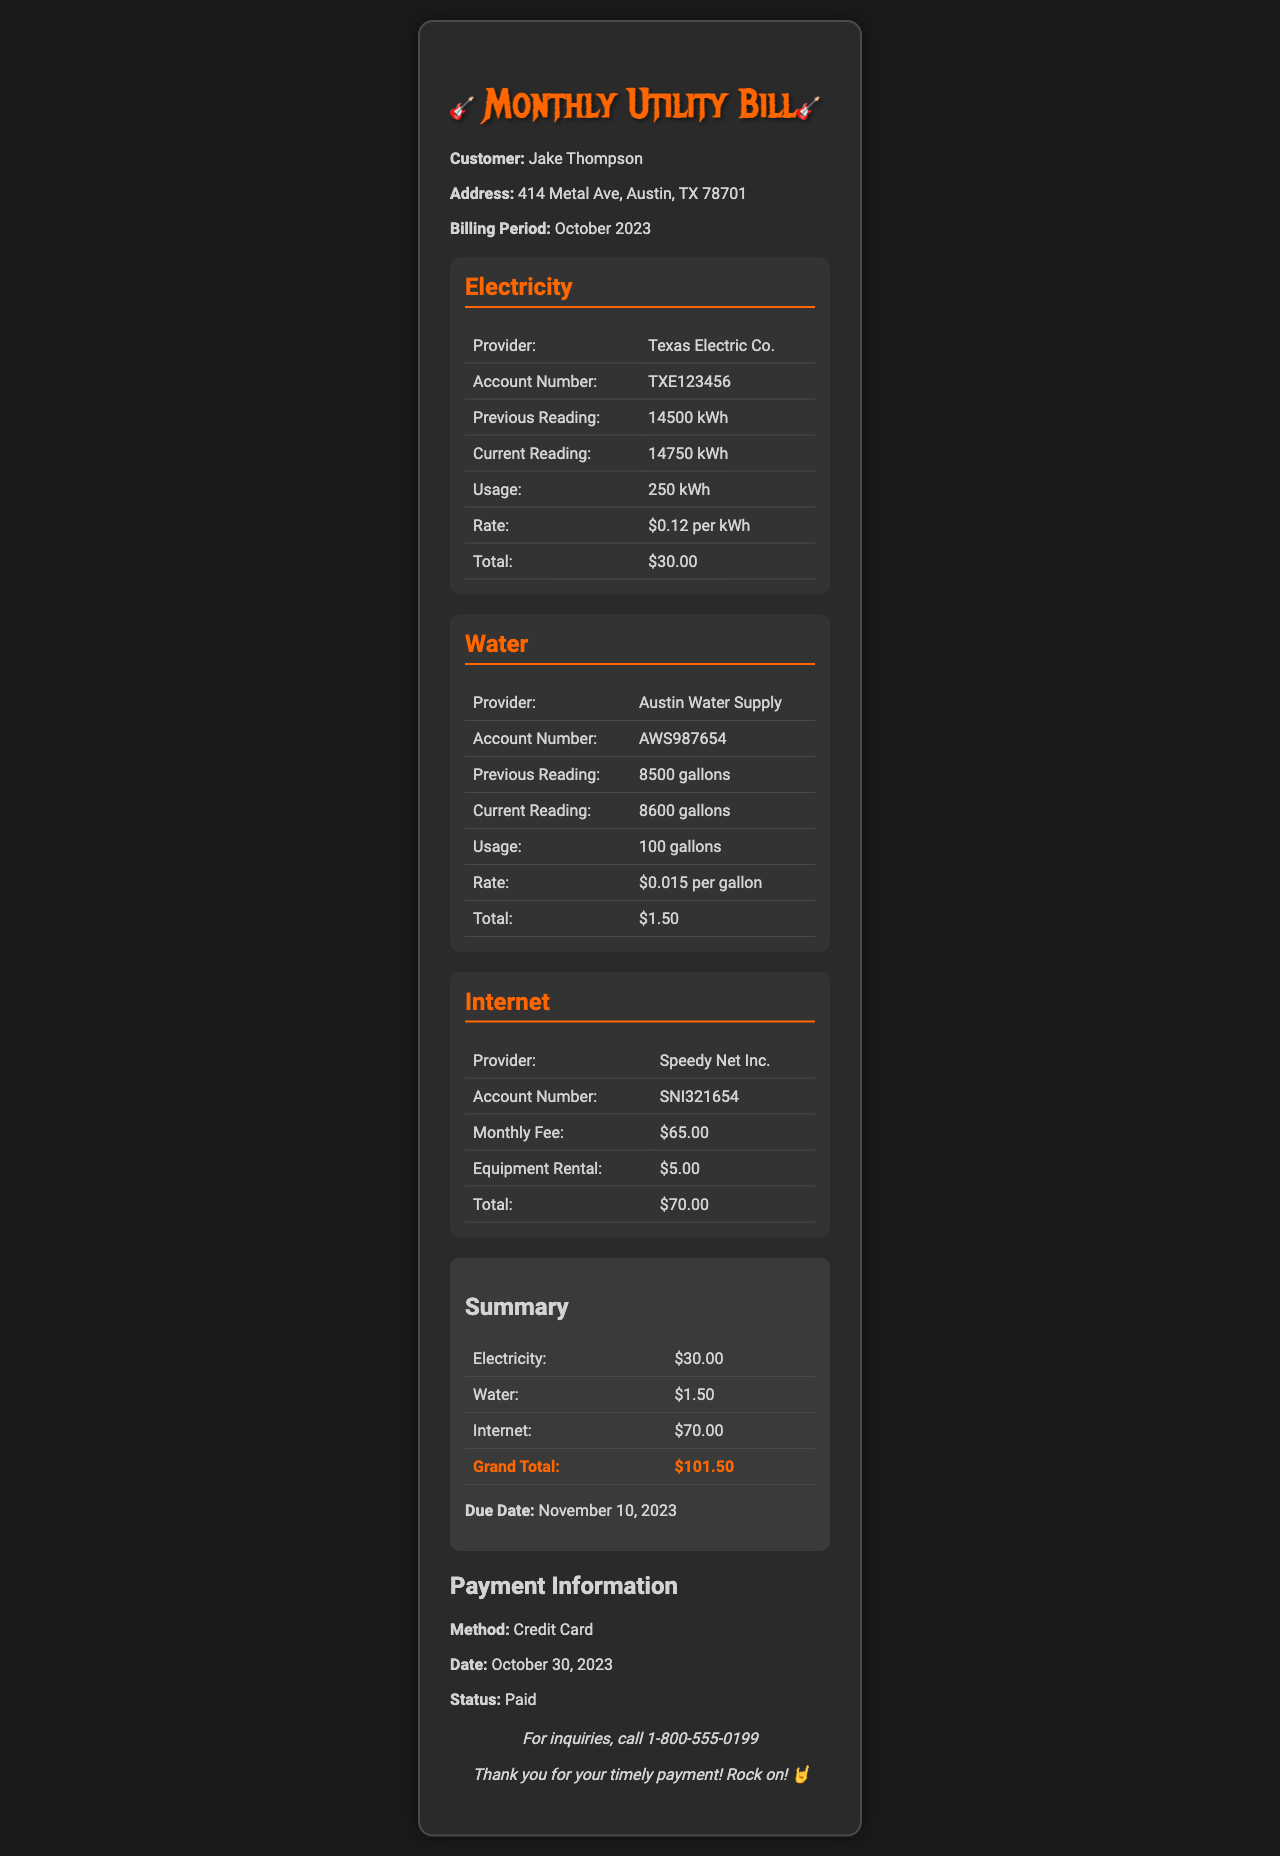What is the name of the electricity provider? The electricity provider listed in the document is Texas Electric Co.
Answer: Texas Electric Co What was the total usage of water? The total usage of water was calculated from the previous and current readings, which is 8600 gallons - 8500 gallons = 100 gallons.
Answer: 100 gallons How much was the grand total for the utility bill? The grand total is provided in the summary section of the document, which is the total of all utility services.
Answer: $101.50 What is the account number for the internet service? The internet account number is found under the internet section, indicated as SNI321654.
Answer: SNI321654 What is the due date for the payment? The due date is clearly stated in the summary section of the document.
Answer: November 10, 2023 What is the rate per kilowatt-hour for electricity? The rate for electricity is specified in the electricity section of the document, which is stated as $0.12 per kWh.
Answer: $0.12 per kWh How much was paid for internet equipment rental? The equipment rental fee for the internet service is mentioned in the internet section.
Answer: $5.00 What payment method was used for this bill? The payment method is listed in the payment information section of the document.
Answer: Credit Card What was Jake Thompson's address? The address of the customer is noted in the header section of the document.
Answer: 414 Metal Ave, Austin, TX 78701 